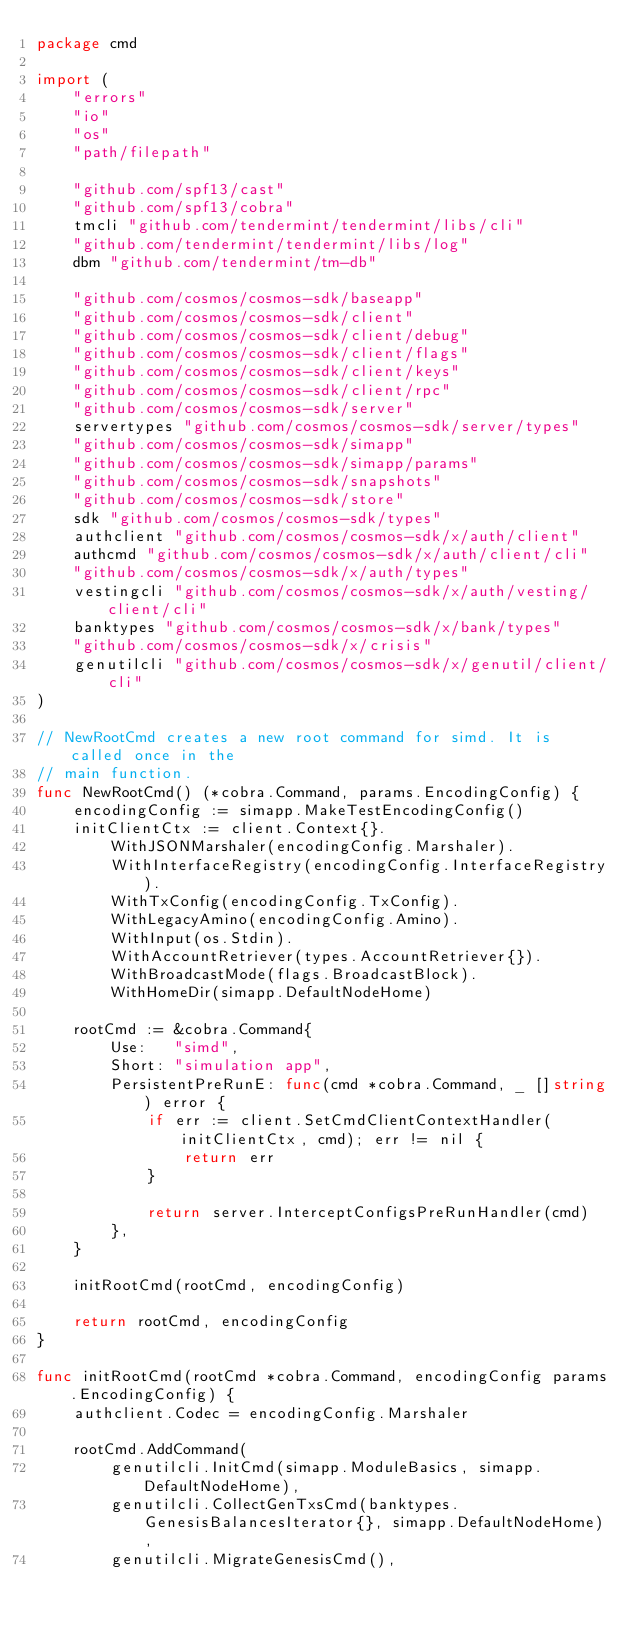<code> <loc_0><loc_0><loc_500><loc_500><_Go_>package cmd

import (
	"errors"
	"io"
	"os"
	"path/filepath"

	"github.com/spf13/cast"
	"github.com/spf13/cobra"
	tmcli "github.com/tendermint/tendermint/libs/cli"
	"github.com/tendermint/tendermint/libs/log"
	dbm "github.com/tendermint/tm-db"

	"github.com/cosmos/cosmos-sdk/baseapp"
	"github.com/cosmos/cosmos-sdk/client"
	"github.com/cosmos/cosmos-sdk/client/debug"
	"github.com/cosmos/cosmos-sdk/client/flags"
	"github.com/cosmos/cosmos-sdk/client/keys"
	"github.com/cosmos/cosmos-sdk/client/rpc"
	"github.com/cosmos/cosmos-sdk/server"
	servertypes "github.com/cosmos/cosmos-sdk/server/types"
	"github.com/cosmos/cosmos-sdk/simapp"
	"github.com/cosmos/cosmos-sdk/simapp/params"
	"github.com/cosmos/cosmos-sdk/snapshots"
	"github.com/cosmos/cosmos-sdk/store"
	sdk "github.com/cosmos/cosmos-sdk/types"
	authclient "github.com/cosmos/cosmos-sdk/x/auth/client"
	authcmd "github.com/cosmos/cosmos-sdk/x/auth/client/cli"
	"github.com/cosmos/cosmos-sdk/x/auth/types"
	vestingcli "github.com/cosmos/cosmos-sdk/x/auth/vesting/client/cli"
	banktypes "github.com/cosmos/cosmos-sdk/x/bank/types"
	"github.com/cosmos/cosmos-sdk/x/crisis"
	genutilcli "github.com/cosmos/cosmos-sdk/x/genutil/client/cli"
)

// NewRootCmd creates a new root command for simd. It is called once in the
// main function.
func NewRootCmd() (*cobra.Command, params.EncodingConfig) {
	encodingConfig := simapp.MakeTestEncodingConfig()
	initClientCtx := client.Context{}.
		WithJSONMarshaler(encodingConfig.Marshaler).
		WithInterfaceRegistry(encodingConfig.InterfaceRegistry).
		WithTxConfig(encodingConfig.TxConfig).
		WithLegacyAmino(encodingConfig.Amino).
		WithInput(os.Stdin).
		WithAccountRetriever(types.AccountRetriever{}).
		WithBroadcastMode(flags.BroadcastBlock).
		WithHomeDir(simapp.DefaultNodeHome)

	rootCmd := &cobra.Command{
		Use:   "simd",
		Short: "simulation app",
		PersistentPreRunE: func(cmd *cobra.Command, _ []string) error {
			if err := client.SetCmdClientContextHandler(initClientCtx, cmd); err != nil {
				return err
			}

			return server.InterceptConfigsPreRunHandler(cmd)
		},
	}

	initRootCmd(rootCmd, encodingConfig)

	return rootCmd, encodingConfig
}

func initRootCmd(rootCmd *cobra.Command, encodingConfig params.EncodingConfig) {
	authclient.Codec = encodingConfig.Marshaler

	rootCmd.AddCommand(
		genutilcli.InitCmd(simapp.ModuleBasics, simapp.DefaultNodeHome),
		genutilcli.CollectGenTxsCmd(banktypes.GenesisBalancesIterator{}, simapp.DefaultNodeHome),
		genutilcli.MigrateGenesisCmd(),</code> 